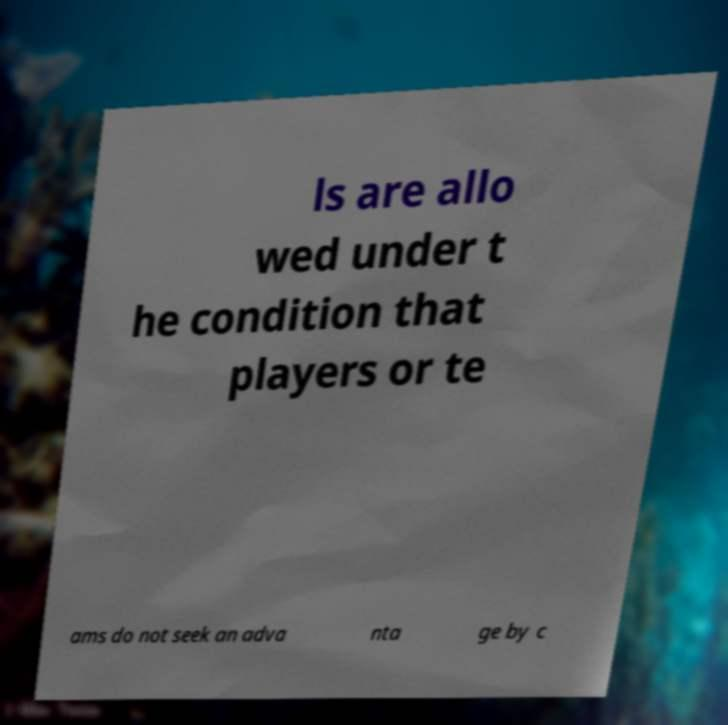I need the written content from this picture converted into text. Can you do that? ls are allo wed under t he condition that players or te ams do not seek an adva nta ge by c 